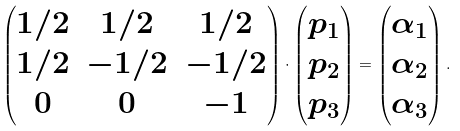Convert formula to latex. <formula><loc_0><loc_0><loc_500><loc_500>\begin{pmatrix} 1 / 2 & 1 / 2 & 1 / 2 \\ 1 / 2 & - 1 / 2 & - 1 / 2 \\ 0 & 0 & - 1 \\ \end{pmatrix} \cdot \begin{pmatrix} p _ { 1 } \\ p _ { 2 } \\ p _ { 3 } \\ \end{pmatrix} = \begin{pmatrix} \alpha _ { 1 } \\ \alpha _ { 2 } \\ \alpha _ { 3 } \\ \end{pmatrix} .</formula> 